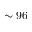Convert formula to latex. <formula><loc_0><loc_0><loc_500><loc_500>\sim 9 6</formula> 